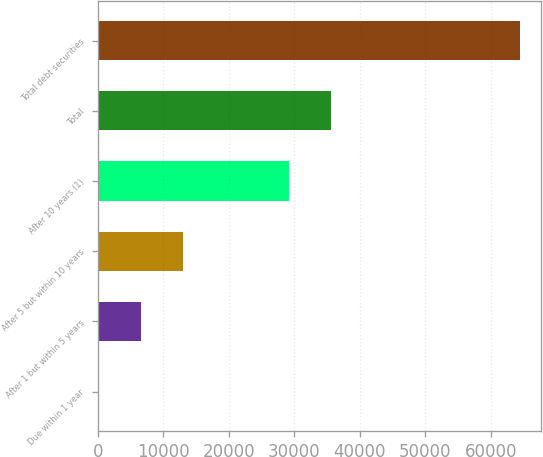Convert chart. <chart><loc_0><loc_0><loc_500><loc_500><bar_chart><fcel>Due within 1 year<fcel>After 1 but within 5 years<fcel>After 5 but within 10 years<fcel>After 10 years (1)<fcel>Total<fcel>Total debt securities<nl><fcel>88<fcel>6525.1<fcel>12962.2<fcel>29155<fcel>35592.1<fcel>64459<nl></chart> 